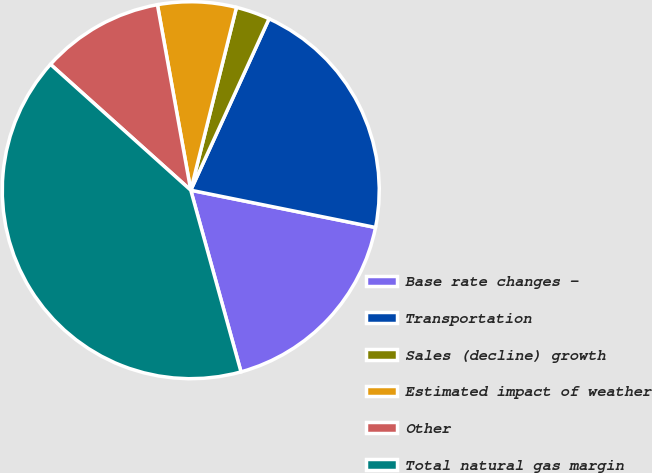Convert chart to OTSL. <chart><loc_0><loc_0><loc_500><loc_500><pie_chart><fcel>Base rate changes -<fcel>Transportation<fcel>Sales (decline) growth<fcel>Estimated impact of weather<fcel>Other<fcel>Total natural gas margin<nl><fcel>17.54%<fcel>21.35%<fcel>2.92%<fcel>6.73%<fcel>10.53%<fcel>40.94%<nl></chart> 